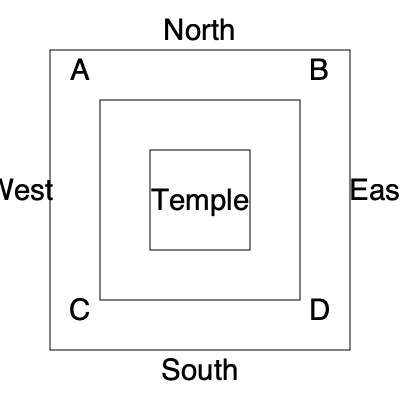Based on the provided map of a Roman forum, which corner would be the most suitable location for the Rostra (speakers' platform) to address the largest audience? To determine the best location for the Rostra, we need to consider the following steps:

1. Understand the layout: The map shows a square forum with a central temple and four corners labeled A, B, C, and D.

2. Consider the purpose of the Rostra: It was used to address large crowds, so it should be placed where it can reach the most people.

3. Analyze the space: The open areas around the temple would be where people gather.

4. Evaluate each corner:
   A (Northwest): Limited space due to proximity to temple and western edge.
   B (Northeast): Open area to the east and south, good visibility.
   C (Southwest): Open area to the south and east, but partially blocked by temple.
   D (Southeast): Largest open area to the north and west, excellent visibility.

5. Historical context: In the late Roman Republic, the Rostra was typically located at the southern end of the Forum Romanum, facing north.

6. Conclusion: Corner D (Southeast) would be the most suitable location, as it provides the largest open space for the audience and aligns with historical precedent.
Answer: Corner D (Southeast) 